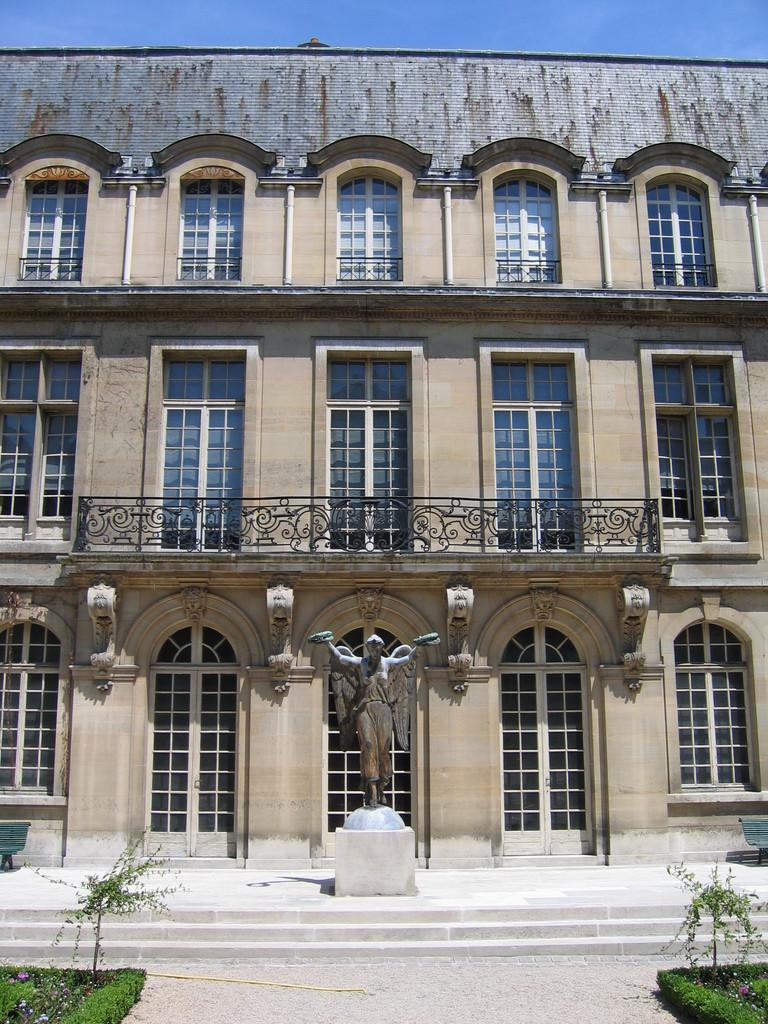What type of structure is in the picture? There is a building in the picture. What feature can be observed on the building? The building has glass windows. What is located in front of the building? There is a statue in front of the building. What type of vegetation is present near the statue? There are plants on either side of the statue. How many eggs are visible on the statue in the image? There are no eggs present on the statue in the image. Is there snow covering the building in the image? There is no snow visible in the image; the weather or season cannot be determined from the provided facts. 